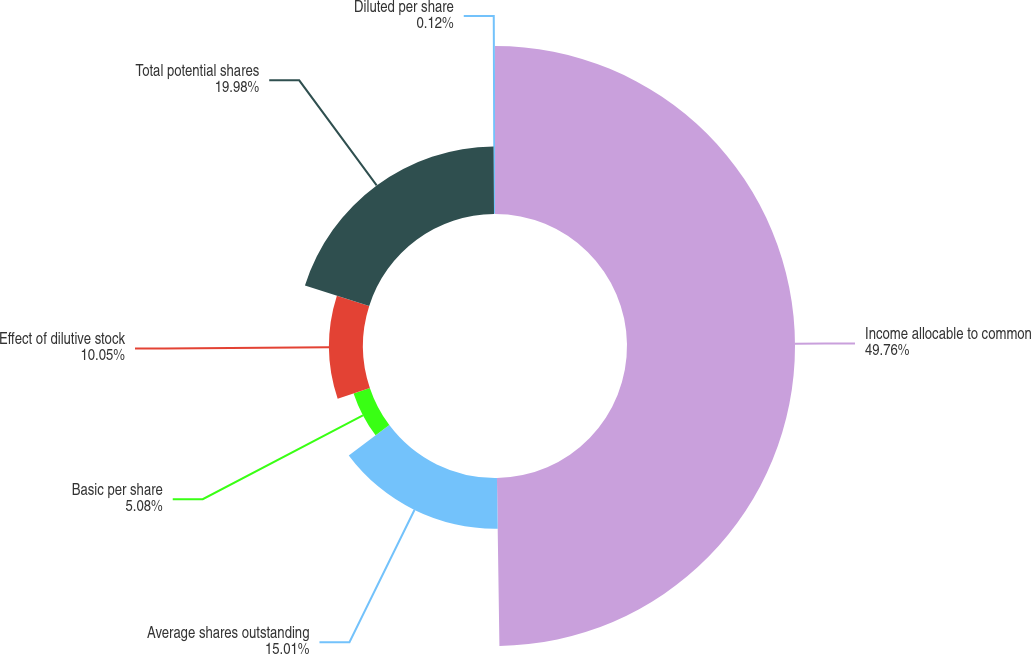Convert chart to OTSL. <chart><loc_0><loc_0><loc_500><loc_500><pie_chart><fcel>Income allocable to common<fcel>Average shares outstanding<fcel>Basic per share<fcel>Effect of dilutive stock<fcel>Total potential shares<fcel>Diluted per share<nl><fcel>49.77%<fcel>15.01%<fcel>5.08%<fcel>10.05%<fcel>19.98%<fcel>0.12%<nl></chart> 